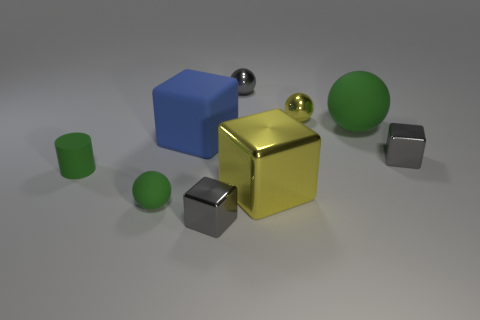What is the cube on the right side of the tiny yellow metallic sphere made of?
Offer a terse response. Metal. There is a tiny gray object to the right of the large thing in front of the small cube that is right of the yellow block; what is its shape?
Give a very brief answer. Cube. Does the blue cube have the same size as the yellow block?
Provide a short and direct response. Yes. How many objects are either small purple metal things or matte things that are in front of the tiny rubber cylinder?
Provide a short and direct response. 1. How many objects are either small gray things that are in front of the tiny green matte cylinder or green balls that are in front of the green cylinder?
Provide a short and direct response. 2. There is a large green matte sphere; are there any large blue rubber things in front of it?
Your answer should be compact. Yes. What is the color of the large rubber cube on the left side of the metal ball in front of the tiny gray object behind the blue block?
Ensure brevity in your answer.  Blue. Is the shape of the blue object the same as the big metal thing?
Give a very brief answer. Yes. What is the color of the tiny cylinder that is made of the same material as the large blue cube?
Make the answer very short. Green. How many things are green matte objects that are on the right side of the small matte cylinder or blue blocks?
Offer a terse response. 3. 